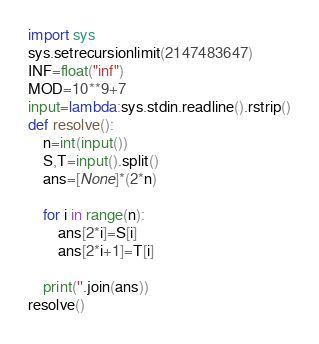Convert code to text. <code><loc_0><loc_0><loc_500><loc_500><_Python_>import sys
sys.setrecursionlimit(2147483647)
INF=float("inf")
MOD=10**9+7
input=lambda:sys.stdin.readline().rstrip()
def resolve():
    n=int(input())
    S,T=input().split()
    ans=[None]*(2*n)

    for i in range(n):
        ans[2*i]=S[i]
        ans[2*i+1]=T[i]

    print(''.join(ans))
resolve()</code> 